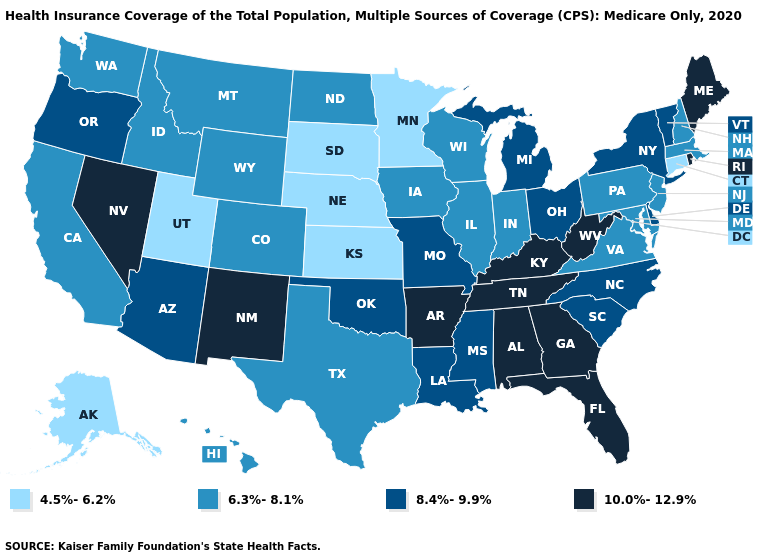What is the highest value in the USA?
Concise answer only. 10.0%-12.9%. What is the lowest value in states that border North Dakota?
Be succinct. 4.5%-6.2%. Name the states that have a value in the range 10.0%-12.9%?
Short answer required. Alabama, Arkansas, Florida, Georgia, Kentucky, Maine, Nevada, New Mexico, Rhode Island, Tennessee, West Virginia. Name the states that have a value in the range 8.4%-9.9%?
Write a very short answer. Arizona, Delaware, Louisiana, Michigan, Mississippi, Missouri, New York, North Carolina, Ohio, Oklahoma, Oregon, South Carolina, Vermont. What is the value of Colorado?
Short answer required. 6.3%-8.1%. Which states have the lowest value in the USA?
Concise answer only. Alaska, Connecticut, Kansas, Minnesota, Nebraska, South Dakota, Utah. What is the value of New Mexico?
Write a very short answer. 10.0%-12.9%. Does Pennsylvania have a higher value than Maine?
Write a very short answer. No. What is the value of Washington?
Quick response, please. 6.3%-8.1%. Name the states that have a value in the range 8.4%-9.9%?
Be succinct. Arizona, Delaware, Louisiana, Michigan, Mississippi, Missouri, New York, North Carolina, Ohio, Oklahoma, Oregon, South Carolina, Vermont. What is the value of West Virginia?
Give a very brief answer. 10.0%-12.9%. Which states have the lowest value in the MidWest?
Quick response, please. Kansas, Minnesota, Nebraska, South Dakota. Name the states that have a value in the range 10.0%-12.9%?
Keep it brief. Alabama, Arkansas, Florida, Georgia, Kentucky, Maine, Nevada, New Mexico, Rhode Island, Tennessee, West Virginia. Which states have the lowest value in the USA?
Write a very short answer. Alaska, Connecticut, Kansas, Minnesota, Nebraska, South Dakota, Utah. Which states have the lowest value in the USA?
Short answer required. Alaska, Connecticut, Kansas, Minnesota, Nebraska, South Dakota, Utah. 